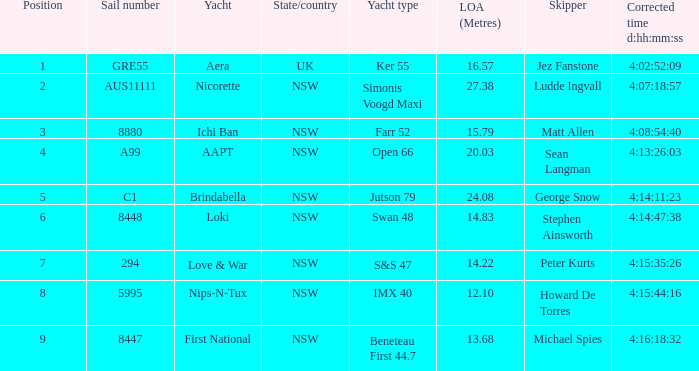Which racing boat had a corrected time of 4:14:11:23? Brindabella. 